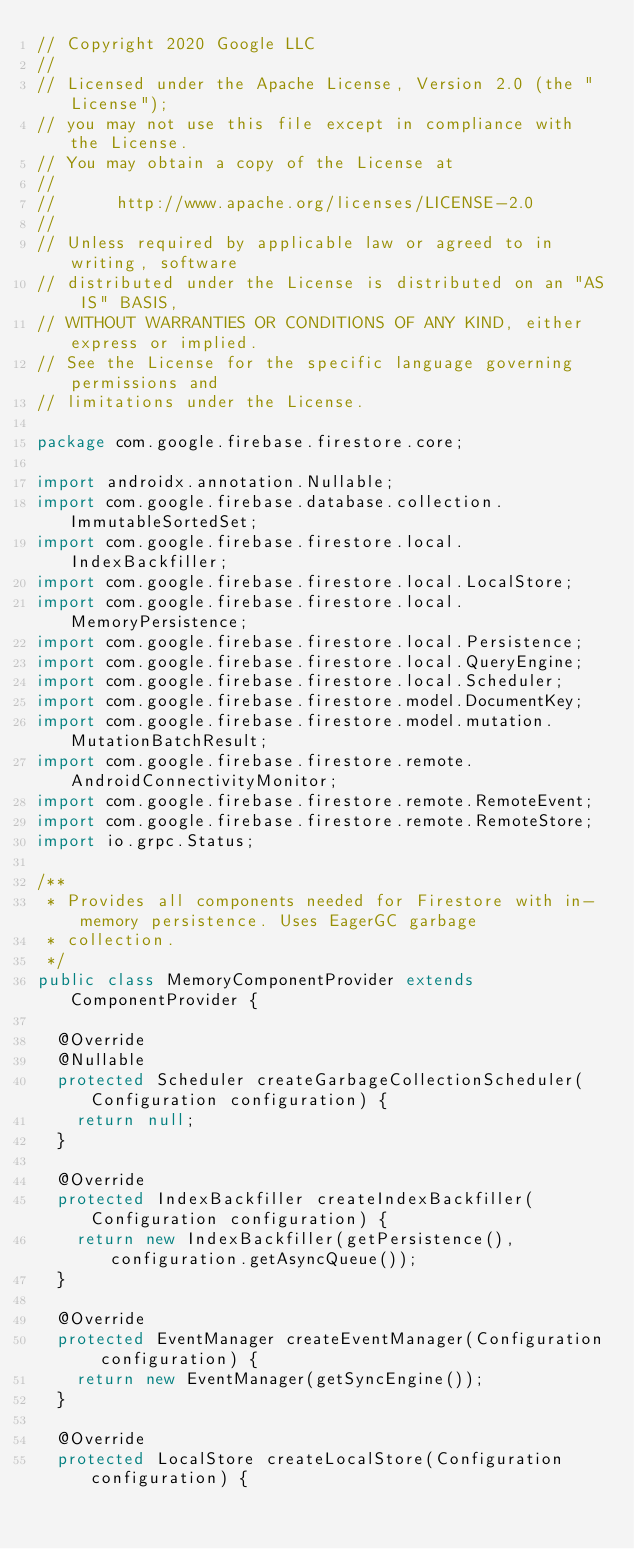Convert code to text. <code><loc_0><loc_0><loc_500><loc_500><_Java_>// Copyright 2020 Google LLC
//
// Licensed under the Apache License, Version 2.0 (the "License");
// you may not use this file except in compliance with the License.
// You may obtain a copy of the License at
//
//      http://www.apache.org/licenses/LICENSE-2.0
//
// Unless required by applicable law or agreed to in writing, software
// distributed under the License is distributed on an "AS IS" BASIS,
// WITHOUT WARRANTIES OR CONDITIONS OF ANY KIND, either express or implied.
// See the License for the specific language governing permissions and
// limitations under the License.

package com.google.firebase.firestore.core;

import androidx.annotation.Nullable;
import com.google.firebase.database.collection.ImmutableSortedSet;
import com.google.firebase.firestore.local.IndexBackfiller;
import com.google.firebase.firestore.local.LocalStore;
import com.google.firebase.firestore.local.MemoryPersistence;
import com.google.firebase.firestore.local.Persistence;
import com.google.firebase.firestore.local.QueryEngine;
import com.google.firebase.firestore.local.Scheduler;
import com.google.firebase.firestore.model.DocumentKey;
import com.google.firebase.firestore.model.mutation.MutationBatchResult;
import com.google.firebase.firestore.remote.AndroidConnectivityMonitor;
import com.google.firebase.firestore.remote.RemoteEvent;
import com.google.firebase.firestore.remote.RemoteStore;
import io.grpc.Status;

/**
 * Provides all components needed for Firestore with in-memory persistence. Uses EagerGC garbage
 * collection.
 */
public class MemoryComponentProvider extends ComponentProvider {

  @Override
  @Nullable
  protected Scheduler createGarbageCollectionScheduler(Configuration configuration) {
    return null;
  }

  @Override
  protected IndexBackfiller createIndexBackfiller(Configuration configuration) {
    return new IndexBackfiller(getPersistence(), configuration.getAsyncQueue());
  }

  @Override
  protected EventManager createEventManager(Configuration configuration) {
    return new EventManager(getSyncEngine());
  }

  @Override
  protected LocalStore createLocalStore(Configuration configuration) {</code> 